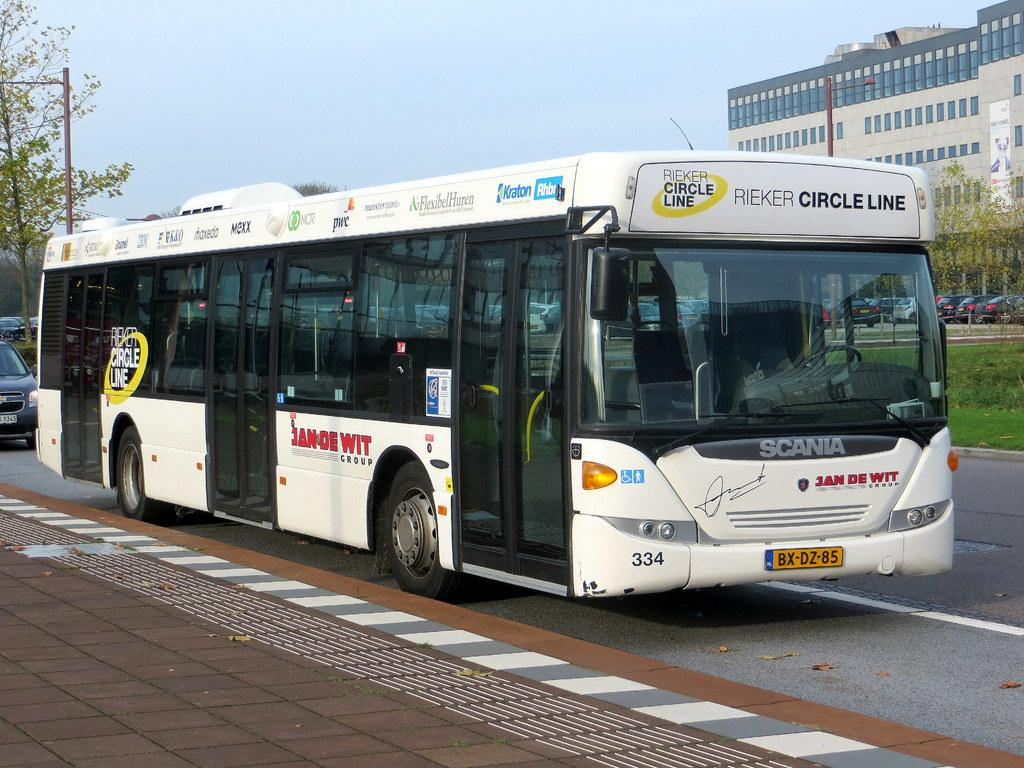Provide a one-sentence caption for the provided image. A Rieker Circle Line transit bus is travelling on the road. 